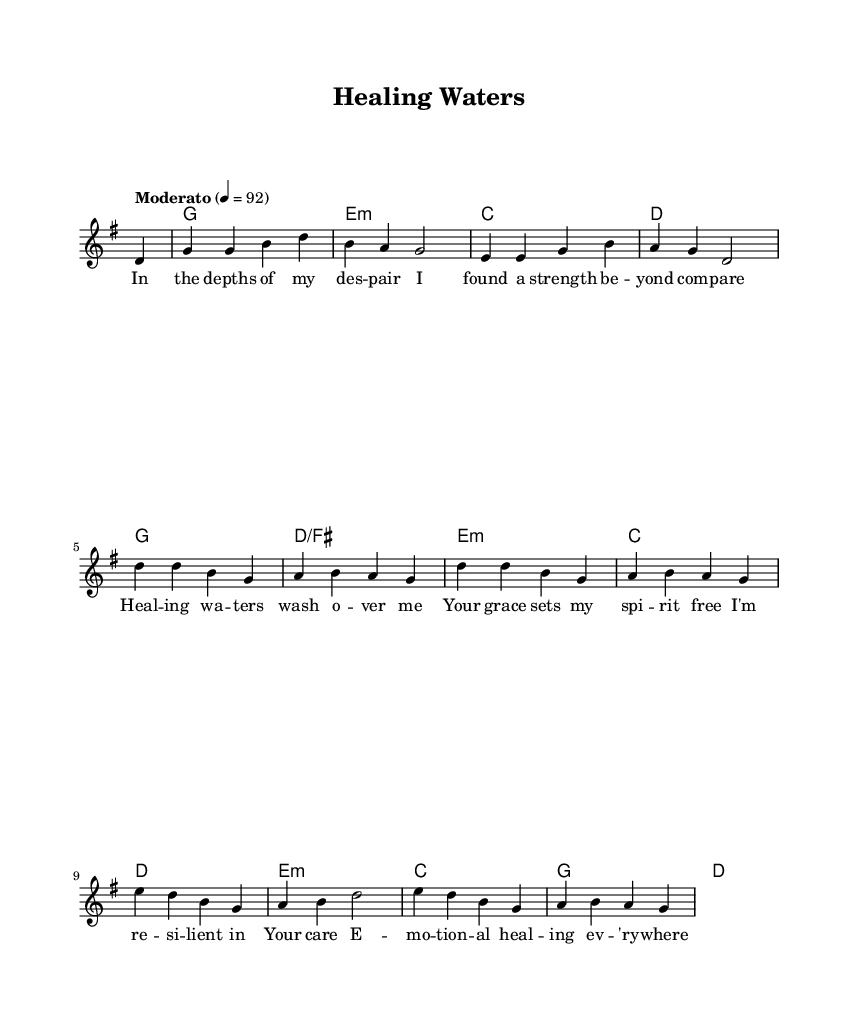What is the key signature of this music? The key signature is indicated at the beginning of the staff, showing one sharp, which corresponds to G major.
Answer: G major What is the time signature of this music? The time signature is shown at the beginning, with "4/4" indicating four beats per measure.
Answer: 4/4 What is the tempo marking of this piece? The tempo marking is indicated in the score as "Moderato" with a metronome marking of 92 beats per minute, suggesting a moderately paced song.
Answer: Moderato How many measures are in the melody section? The melody consists of twelve measures, counted from the beginning to the end of the written portion.
Answer: Twelve In which part of the score can we find the lyrics? The lyrics are aligned underneath the melody and are marked with the \new Lyrics directive, indicating they correspond directly to that vocal line.
Answer: Under the melody What theme does the song primarily explore? The lyrics revolve around themes of emotional healing and resilience, as indicated by phrases in the text focused on strength and grace.
Answer: Emotional healing and resilience Which chord appears most frequently in the harmonies? The G major chord appears the most, present several times throughout the harmonic structure of the piece.
Answer: G 